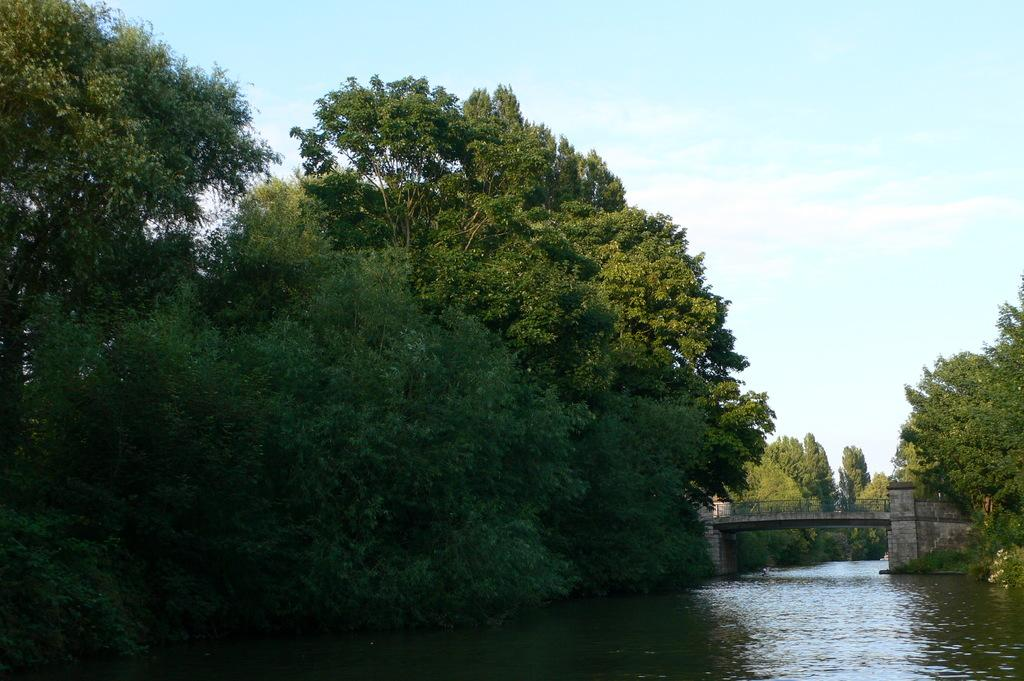What is the primary element visible in the image? There is water in the image. What type of natural vegetation can be seen in the image? There are trees in the image. What structure is present over the water in the image? There is a bridge over the water in the image. What type of selection process is being used to choose the best vest in the image? There is no selection process or vest present in the image. How does the quiet environment contribute to the overall atmosphere of the image? The image does not depict a quiet environment, nor does it provide information about the atmosphere. 